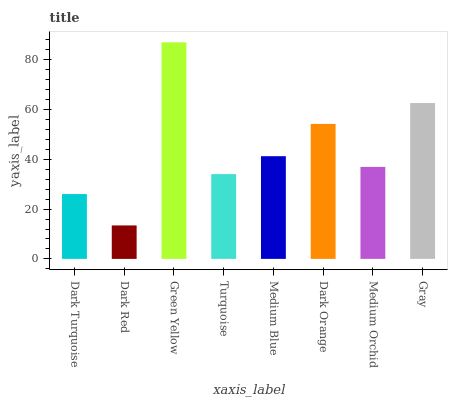Is Dark Red the minimum?
Answer yes or no. Yes. Is Green Yellow the maximum?
Answer yes or no. Yes. Is Green Yellow the minimum?
Answer yes or no. No. Is Dark Red the maximum?
Answer yes or no. No. Is Green Yellow greater than Dark Red?
Answer yes or no. Yes. Is Dark Red less than Green Yellow?
Answer yes or no. Yes. Is Dark Red greater than Green Yellow?
Answer yes or no. No. Is Green Yellow less than Dark Red?
Answer yes or no. No. Is Medium Blue the high median?
Answer yes or no. Yes. Is Medium Orchid the low median?
Answer yes or no. Yes. Is Green Yellow the high median?
Answer yes or no. No. Is Dark Turquoise the low median?
Answer yes or no. No. 